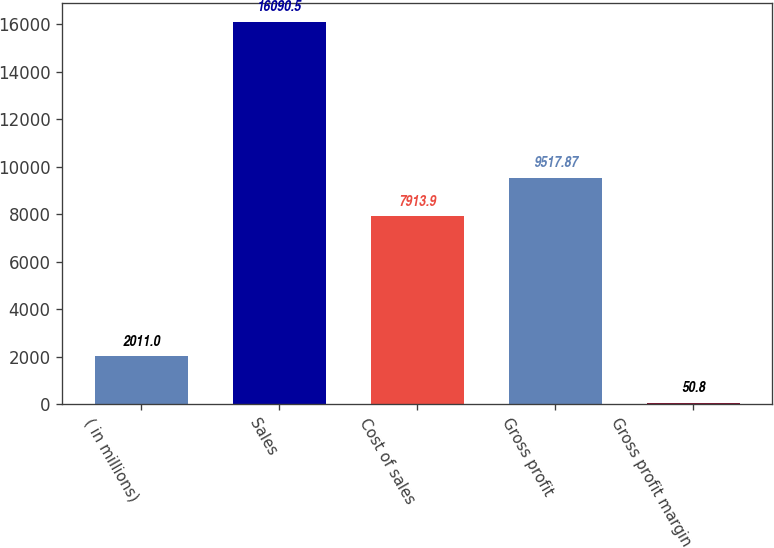Convert chart. <chart><loc_0><loc_0><loc_500><loc_500><bar_chart><fcel>( in millions)<fcel>Sales<fcel>Cost of sales<fcel>Gross profit<fcel>Gross profit margin<nl><fcel>2011<fcel>16090.5<fcel>7913.9<fcel>9517.87<fcel>50.8<nl></chart> 